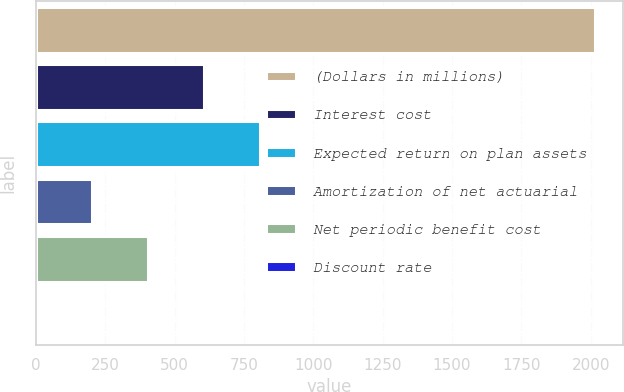Convert chart. <chart><loc_0><loc_0><loc_500><loc_500><bar_chart><fcel>(Dollars in millions)<fcel>Interest cost<fcel>Expected return on plan assets<fcel>Amortization of net actuarial<fcel>Net periodic benefit cost<fcel>Discount rate<nl><fcel>2017<fcel>606.88<fcel>808.32<fcel>204<fcel>405.44<fcel>2.56<nl></chart> 